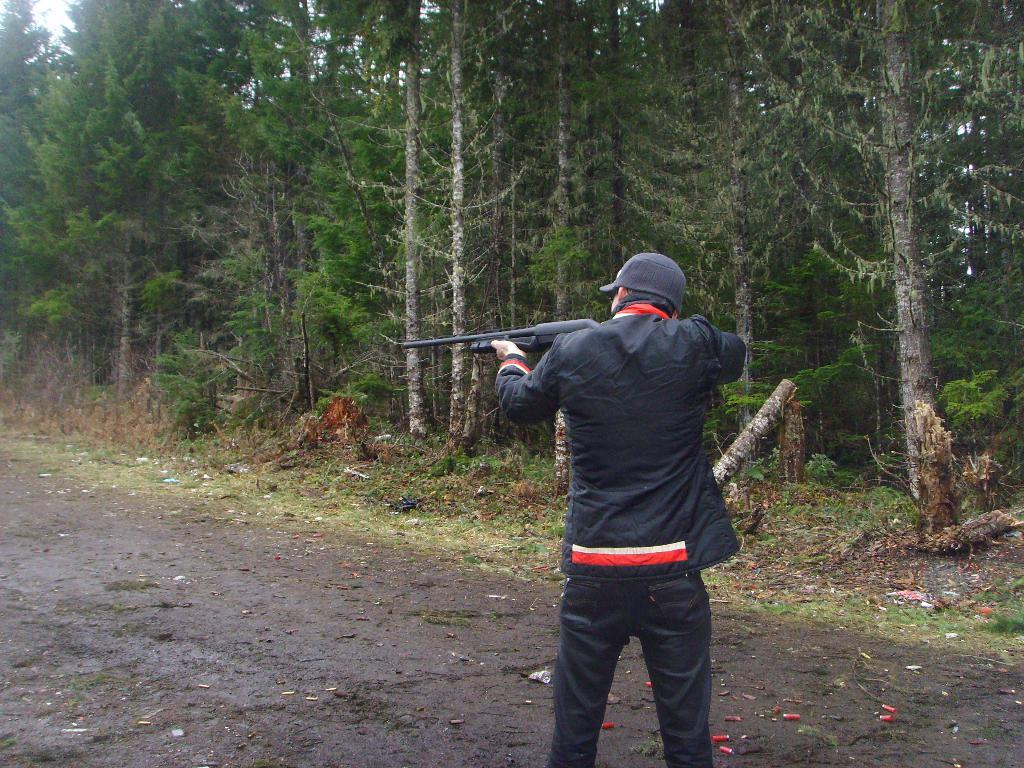What is the main subject of the image? There is a man in the image. What is the man doing in the image? The man is standing in the image. What is the man holding in the image? The man is holding a gun in the image. What is the man wearing in the image? The man is wearing a black dress and a black cap in the image. What can be seen in the background of the image? There are plants and trees in the background of the image. What type of wood is the man's hair made of in the image? The man's hair is not made of wood; he is wearing a black cap in the image. What year is depicted in the image? The provided facts do not mention any specific year, so it cannot be determined from the image. 